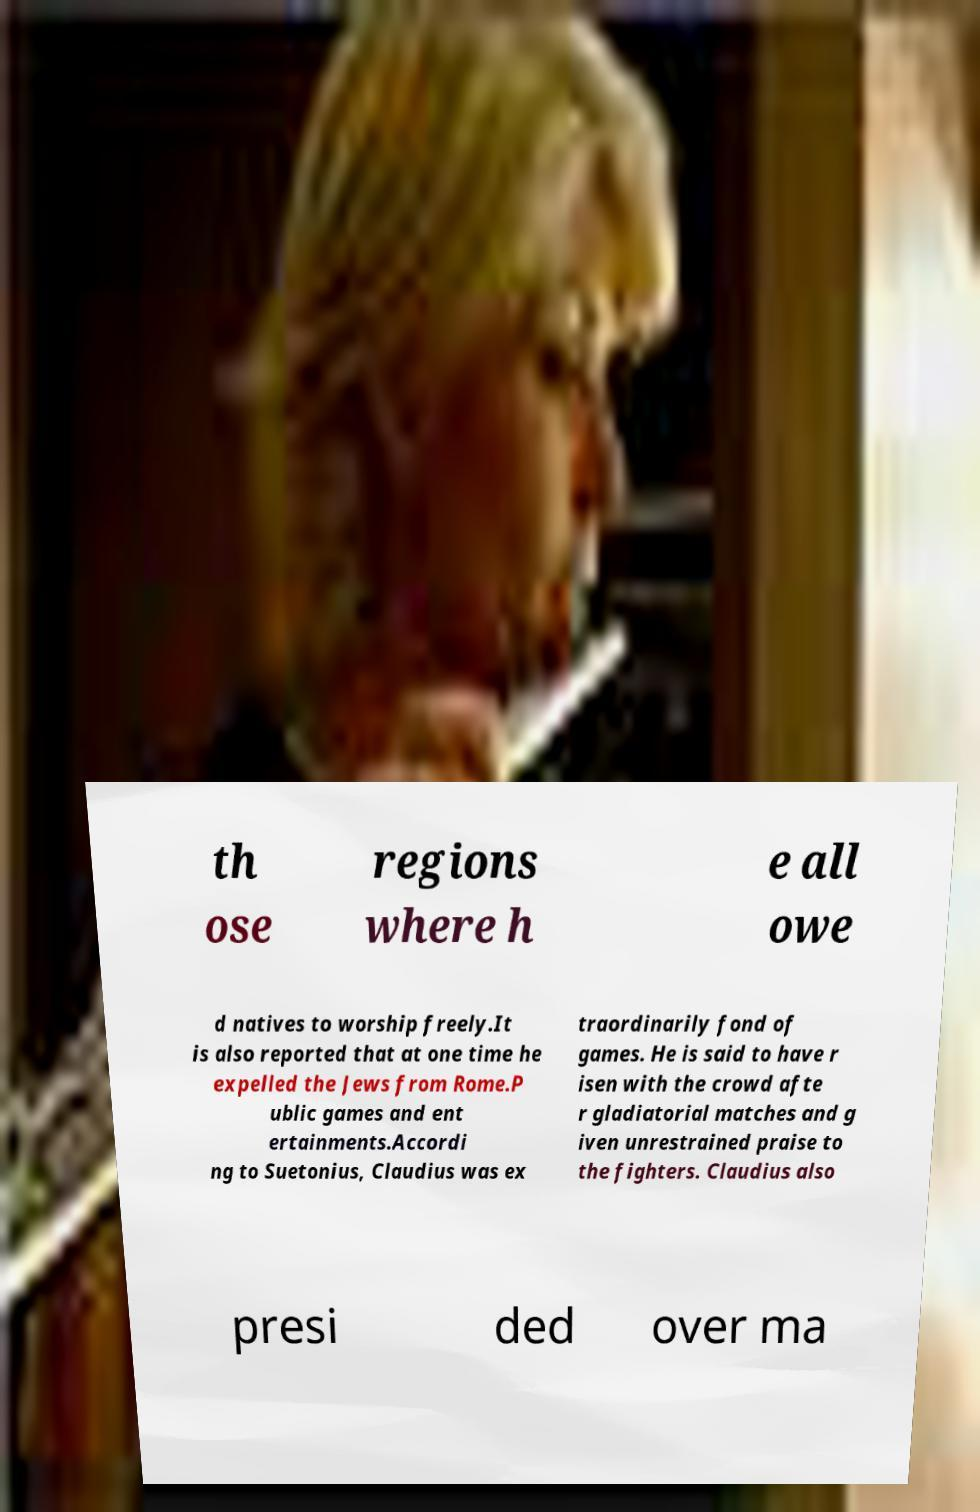Could you assist in decoding the text presented in this image and type it out clearly? th ose regions where h e all owe d natives to worship freely.It is also reported that at one time he expelled the Jews from Rome.P ublic games and ent ertainments.Accordi ng to Suetonius, Claudius was ex traordinarily fond of games. He is said to have r isen with the crowd afte r gladiatorial matches and g iven unrestrained praise to the fighters. Claudius also presi ded over ma 